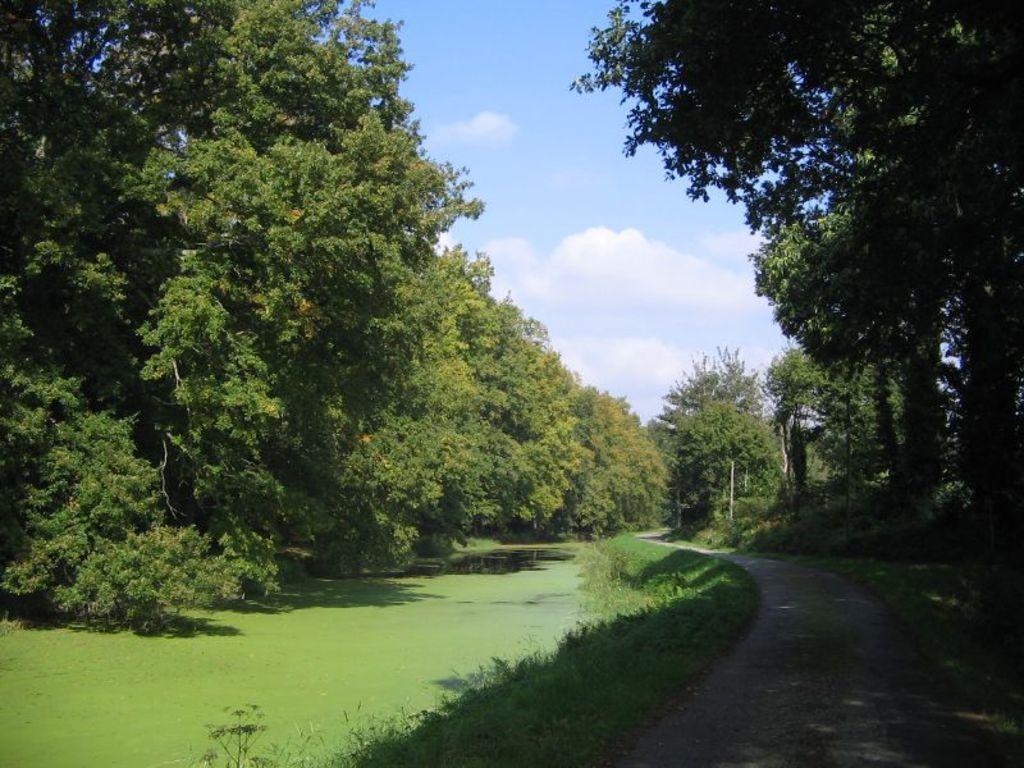Could you give a brief overview of what you see in this image? In this image we can see a pond. There are many trees and plants in the image. There is a road in the image. There is a blue and cloudy sky in the image. 